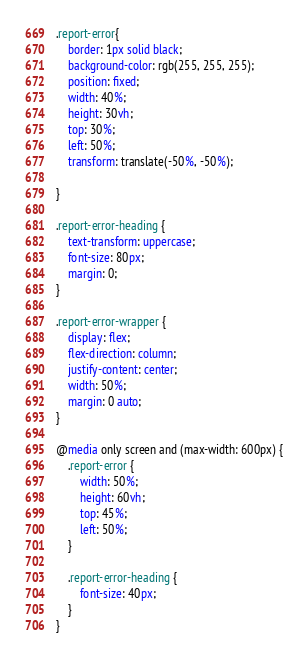Convert code to text. <code><loc_0><loc_0><loc_500><loc_500><_CSS_>.report-error{
    border: 1px solid black;
    background-color: rgb(255, 255, 255);
    position: fixed;
    width: 40%;
    height: 30vh;
    top: 30%;
    left: 50%;
    transform: translate(-50%, -50%);

}

.report-error-heading {
    text-transform: uppercase;
    font-size: 80px;
    margin: 0;
}

.report-error-wrapper {
    display: flex;
    flex-direction: column;
    justify-content: center;
    width: 50%;
    margin: 0 auto;
}

@media only screen and (max-width: 600px) {
    .report-error {
        width: 50%;
        height: 60vh;
        top: 45%;
        left: 50%;
    }

    .report-error-heading {
        font-size: 40px;
    }
}</code> 